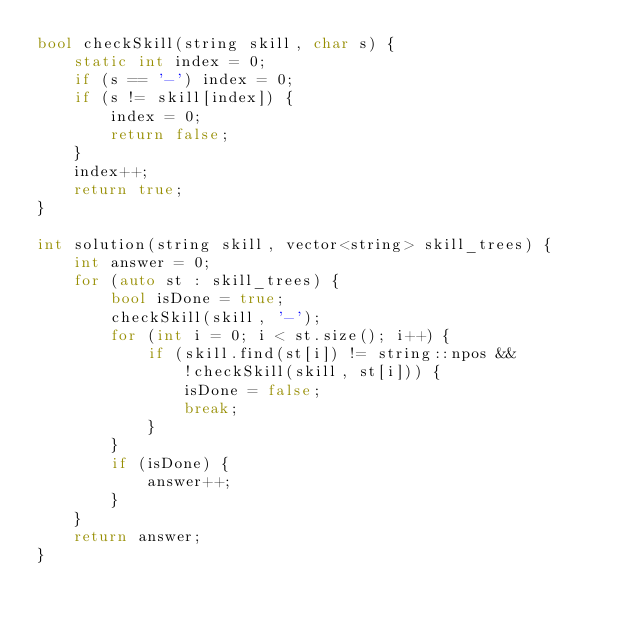Convert code to text. <code><loc_0><loc_0><loc_500><loc_500><_C++_>bool checkSkill(string skill, char s) {
    static int index = 0;
    if (s == '-') index = 0;
    if (s != skill[index]) {
        index = 0;
        return false;    
    }
    index++;
    return true;
}

int solution(string skill, vector<string> skill_trees) {
    int answer = 0;
    for (auto st : skill_trees) {
        bool isDone = true;
        checkSkill(skill, '-');
        for (int i = 0; i < st.size(); i++) {
            if (skill.find(st[i]) != string::npos && 
                !checkSkill(skill, st[i])) {
                isDone = false;
                break;
            }
        }
        if (isDone) {
            answer++;
        }
    }
    return answer;
}</code> 